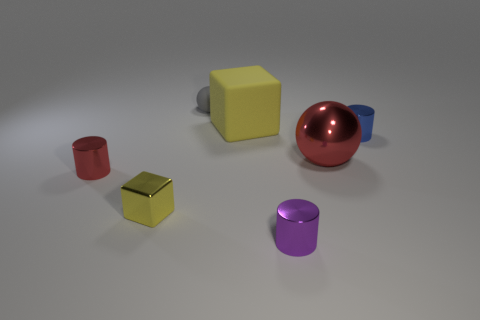What color is the large object that is in front of the cube that is on the right side of the ball to the left of the purple cylinder?
Ensure brevity in your answer.  Red. What color is the big object that is the same material as the tiny gray ball?
Offer a terse response. Yellow. Is there any other thing that has the same size as the red metal ball?
Offer a terse response. Yes. What number of things are tiny shiny cylinders to the left of the yellow metal block or small cylinders that are in front of the large shiny thing?
Ensure brevity in your answer.  2. Is the size of the matte object in front of the gray sphere the same as the red metal thing to the left of the tiny purple cylinder?
Provide a succinct answer. No. The tiny object that is the same shape as the big metallic thing is what color?
Keep it short and to the point. Gray. Are there any other things that are the same shape as the big yellow matte thing?
Ensure brevity in your answer.  Yes. Are there more tiny shiny cylinders that are to the left of the blue shiny thing than tiny yellow shiny objects in front of the large yellow rubber cube?
Your response must be concise. Yes. What size is the metallic cylinder that is behind the tiny metal cylinder that is left of the tiny shiny cylinder that is in front of the small red thing?
Make the answer very short. Small. Is the blue object made of the same material as the red thing that is left of the small yellow block?
Give a very brief answer. Yes. 